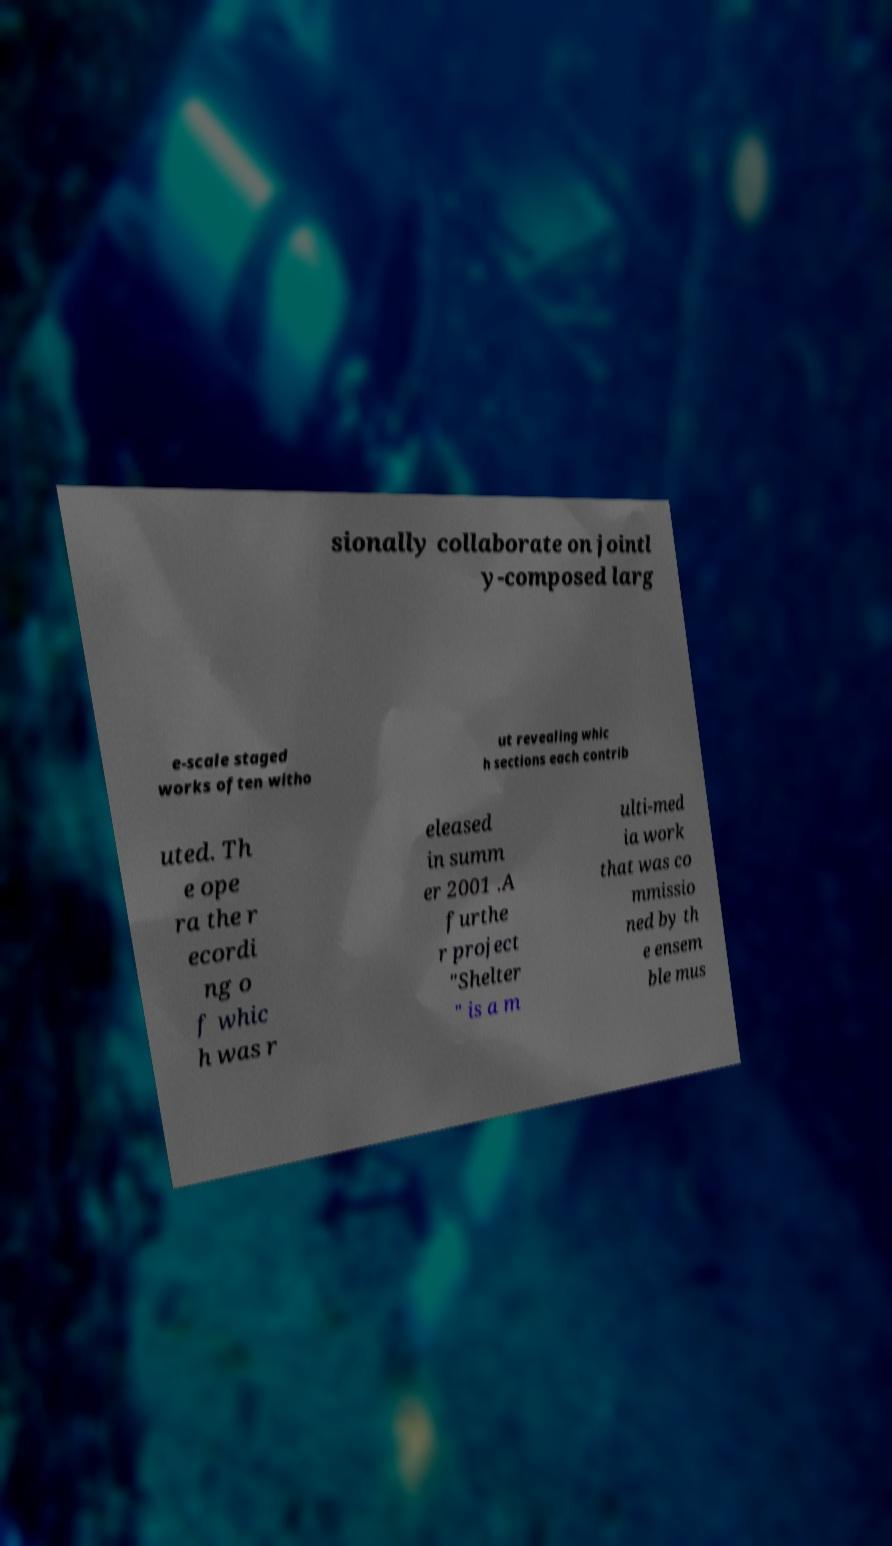Please identify and transcribe the text found in this image. sionally collaborate on jointl y-composed larg e-scale staged works often witho ut revealing whic h sections each contrib uted. Th e ope ra the r ecordi ng o f whic h was r eleased in summ er 2001 .A furthe r project "Shelter " is a m ulti-med ia work that was co mmissio ned by th e ensem ble mus 